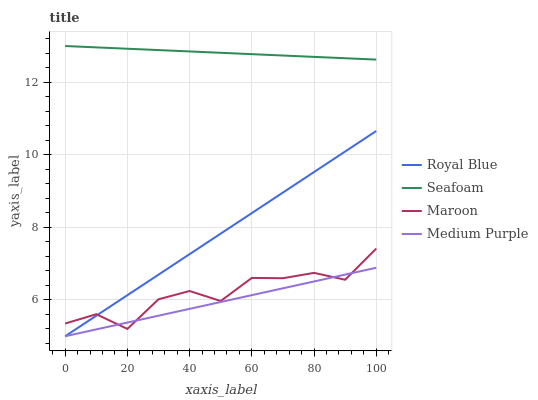Does Royal Blue have the minimum area under the curve?
Answer yes or no. No. Does Royal Blue have the maximum area under the curve?
Answer yes or no. No. Is Royal Blue the smoothest?
Answer yes or no. No. Is Royal Blue the roughest?
Answer yes or no. No. Does Seafoam have the lowest value?
Answer yes or no. No. Does Royal Blue have the highest value?
Answer yes or no. No. Is Royal Blue less than Seafoam?
Answer yes or no. Yes. Is Seafoam greater than Medium Purple?
Answer yes or no. Yes. Does Royal Blue intersect Seafoam?
Answer yes or no. No. 